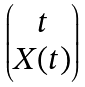Convert formula to latex. <formula><loc_0><loc_0><loc_500><loc_500>\begin{pmatrix} t \\ X ( t ) \end{pmatrix}</formula> 